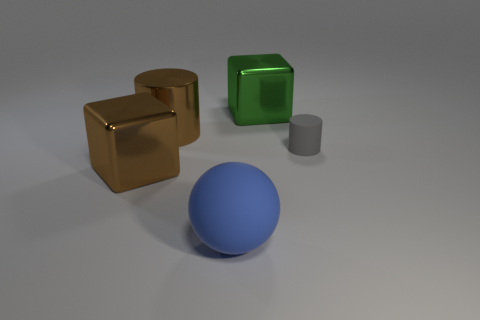Add 5 brown cylinders. How many objects exist? 10 Subtract all cubes. How many objects are left? 3 Add 4 small brown metal cubes. How many small brown metal cubes exist? 4 Subtract 0 green spheres. How many objects are left? 5 Subtract all tiny brown cylinders. Subtract all big metallic objects. How many objects are left? 2 Add 2 big green blocks. How many big green blocks are left? 3 